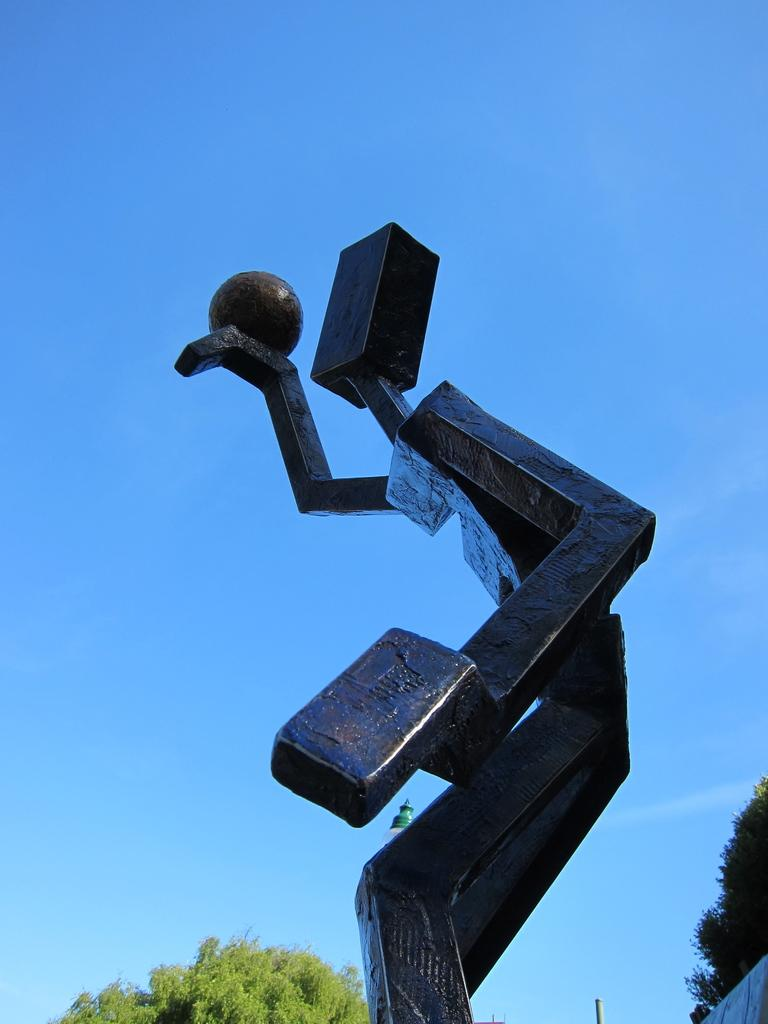What is the main subject in the front of the image? There is a statue in the front of the image. What can be seen in the background of the image? There are trees in the background of the image. What is visible at the top of the image? The sky is visible at the top of the image. Where is the aunt standing in the image? There is no aunt present in the image. What type of scarecrow can be seen in the image? There is no scarecrow present in the image. 